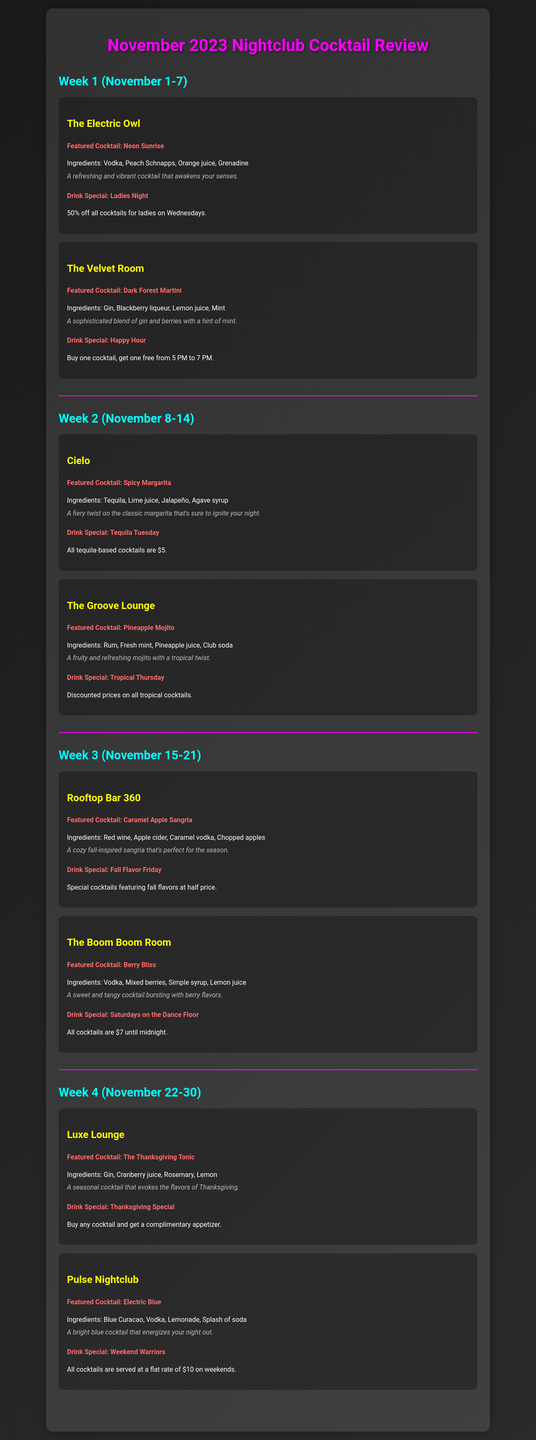What is the featured cocktail at The Electric Owl? The featured cocktail is listed under The Electric Owl section, which is "Neon Sunrise."
Answer: Neon Sunrise What drink special does The Velvet Room offer? The drink special is described in The Velvet Room section as "Buy one cocktail, get one free from 5 PM to 7 PM."
Answer: Buy one cocktail, get one free from 5 PM to 7 PM How many nightclubs are reviewed in total? The document lists several nightclubs, specifically one for each week, and there are four weeks, with two nightclubs per week. Thus, there are 8 nightclubs total.
Answer: 8 Which cocktail features jalapeño as an ingredient? The recipe combinations for the cocktails reveal that "Spicy Margarita" contains jalapeño.
Answer: Spicy Margarita What is the drink special at Luxe Lounge? The drink special mentioned for Luxe Lounge is "Buy any cocktail and get a complimentary appetizer."
Answer: Buy any cocktail and get a complimentary appetizer How much are tequila-based cocktails on Tequila Tuesday? This specific drink special details that tequila-based cocktails are priced at $5 during Tequila Tuesday.
Answer: $5 What cocktail is featured at Rooftop Bar 360? The featured cocktail is listed in Rooftop Bar 360, which is "Caramel Apple Sangria."
Answer: Caramel Apple Sangria When does the Happy Hour special occur at The Velvet Room? The Happy Hour special is specified to occur between 5 PM to 7 PM.
Answer: 5 PM to 7 PM What is the theme of the cocktail at Luxe Lounge? The theme for the cocktail at Luxe Lounge is associated with the flavors of Thanksgiving, as indicated in its description.
Answer: Thanksgiving 